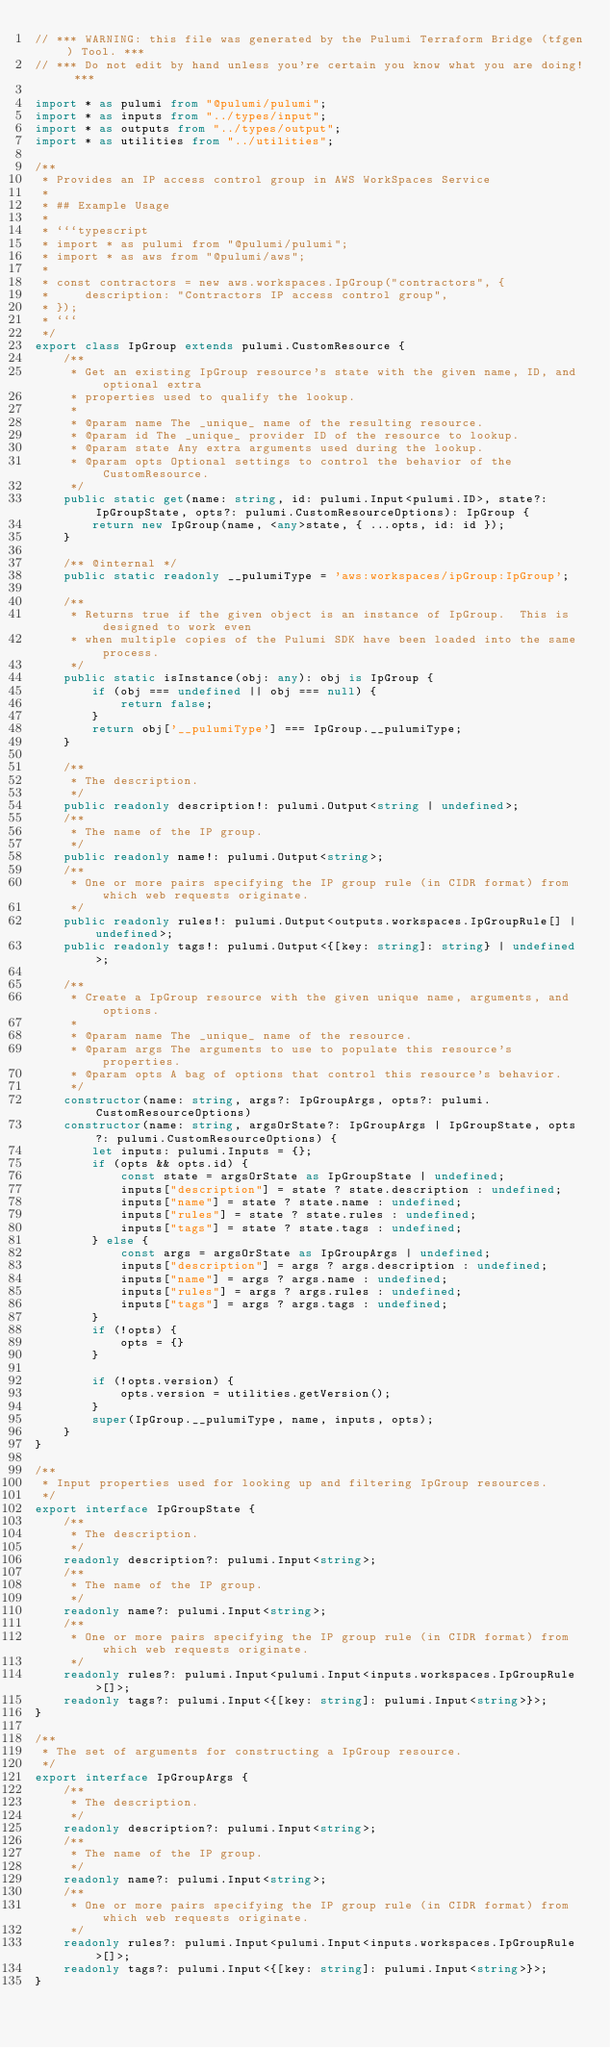Convert code to text. <code><loc_0><loc_0><loc_500><loc_500><_TypeScript_>// *** WARNING: this file was generated by the Pulumi Terraform Bridge (tfgen) Tool. ***
// *** Do not edit by hand unless you're certain you know what you are doing! ***

import * as pulumi from "@pulumi/pulumi";
import * as inputs from "../types/input";
import * as outputs from "../types/output";
import * as utilities from "../utilities";

/**
 * Provides an IP access control group in AWS WorkSpaces Service
 *
 * ## Example Usage
 *
 * ```typescript
 * import * as pulumi from "@pulumi/pulumi";
 * import * as aws from "@pulumi/aws";
 *
 * const contractors = new aws.workspaces.IpGroup("contractors", {
 *     description: "Contractors IP access control group",
 * });
 * ```
 */
export class IpGroup extends pulumi.CustomResource {
    /**
     * Get an existing IpGroup resource's state with the given name, ID, and optional extra
     * properties used to qualify the lookup.
     *
     * @param name The _unique_ name of the resulting resource.
     * @param id The _unique_ provider ID of the resource to lookup.
     * @param state Any extra arguments used during the lookup.
     * @param opts Optional settings to control the behavior of the CustomResource.
     */
    public static get(name: string, id: pulumi.Input<pulumi.ID>, state?: IpGroupState, opts?: pulumi.CustomResourceOptions): IpGroup {
        return new IpGroup(name, <any>state, { ...opts, id: id });
    }

    /** @internal */
    public static readonly __pulumiType = 'aws:workspaces/ipGroup:IpGroup';

    /**
     * Returns true if the given object is an instance of IpGroup.  This is designed to work even
     * when multiple copies of the Pulumi SDK have been loaded into the same process.
     */
    public static isInstance(obj: any): obj is IpGroup {
        if (obj === undefined || obj === null) {
            return false;
        }
        return obj['__pulumiType'] === IpGroup.__pulumiType;
    }

    /**
     * The description.
     */
    public readonly description!: pulumi.Output<string | undefined>;
    /**
     * The name of the IP group.
     */
    public readonly name!: pulumi.Output<string>;
    /**
     * One or more pairs specifying the IP group rule (in CIDR format) from which web requests originate.
     */
    public readonly rules!: pulumi.Output<outputs.workspaces.IpGroupRule[] | undefined>;
    public readonly tags!: pulumi.Output<{[key: string]: string} | undefined>;

    /**
     * Create a IpGroup resource with the given unique name, arguments, and options.
     *
     * @param name The _unique_ name of the resource.
     * @param args The arguments to use to populate this resource's properties.
     * @param opts A bag of options that control this resource's behavior.
     */
    constructor(name: string, args?: IpGroupArgs, opts?: pulumi.CustomResourceOptions)
    constructor(name: string, argsOrState?: IpGroupArgs | IpGroupState, opts?: pulumi.CustomResourceOptions) {
        let inputs: pulumi.Inputs = {};
        if (opts && opts.id) {
            const state = argsOrState as IpGroupState | undefined;
            inputs["description"] = state ? state.description : undefined;
            inputs["name"] = state ? state.name : undefined;
            inputs["rules"] = state ? state.rules : undefined;
            inputs["tags"] = state ? state.tags : undefined;
        } else {
            const args = argsOrState as IpGroupArgs | undefined;
            inputs["description"] = args ? args.description : undefined;
            inputs["name"] = args ? args.name : undefined;
            inputs["rules"] = args ? args.rules : undefined;
            inputs["tags"] = args ? args.tags : undefined;
        }
        if (!opts) {
            opts = {}
        }

        if (!opts.version) {
            opts.version = utilities.getVersion();
        }
        super(IpGroup.__pulumiType, name, inputs, opts);
    }
}

/**
 * Input properties used for looking up and filtering IpGroup resources.
 */
export interface IpGroupState {
    /**
     * The description.
     */
    readonly description?: pulumi.Input<string>;
    /**
     * The name of the IP group.
     */
    readonly name?: pulumi.Input<string>;
    /**
     * One or more pairs specifying the IP group rule (in CIDR format) from which web requests originate.
     */
    readonly rules?: pulumi.Input<pulumi.Input<inputs.workspaces.IpGroupRule>[]>;
    readonly tags?: pulumi.Input<{[key: string]: pulumi.Input<string>}>;
}

/**
 * The set of arguments for constructing a IpGroup resource.
 */
export interface IpGroupArgs {
    /**
     * The description.
     */
    readonly description?: pulumi.Input<string>;
    /**
     * The name of the IP group.
     */
    readonly name?: pulumi.Input<string>;
    /**
     * One or more pairs specifying the IP group rule (in CIDR format) from which web requests originate.
     */
    readonly rules?: pulumi.Input<pulumi.Input<inputs.workspaces.IpGroupRule>[]>;
    readonly tags?: pulumi.Input<{[key: string]: pulumi.Input<string>}>;
}
</code> 